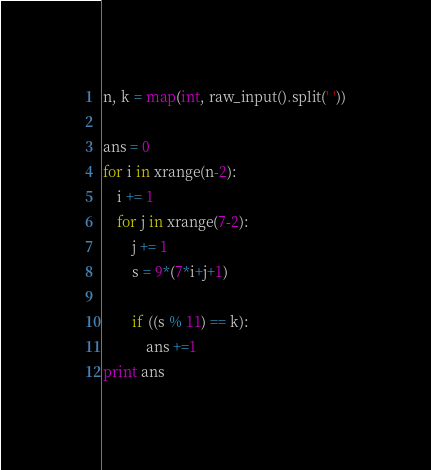Convert code to text. <code><loc_0><loc_0><loc_500><loc_500><_Python_>n, k = map(int, raw_input().split(' '))

ans = 0
for i in xrange(n-2):
    i += 1
    for j in xrange(7-2):
        j += 1
        s = 9*(7*i+j+1)

        if ((s % 11) == k):
            ans +=1
print ans
</code> 